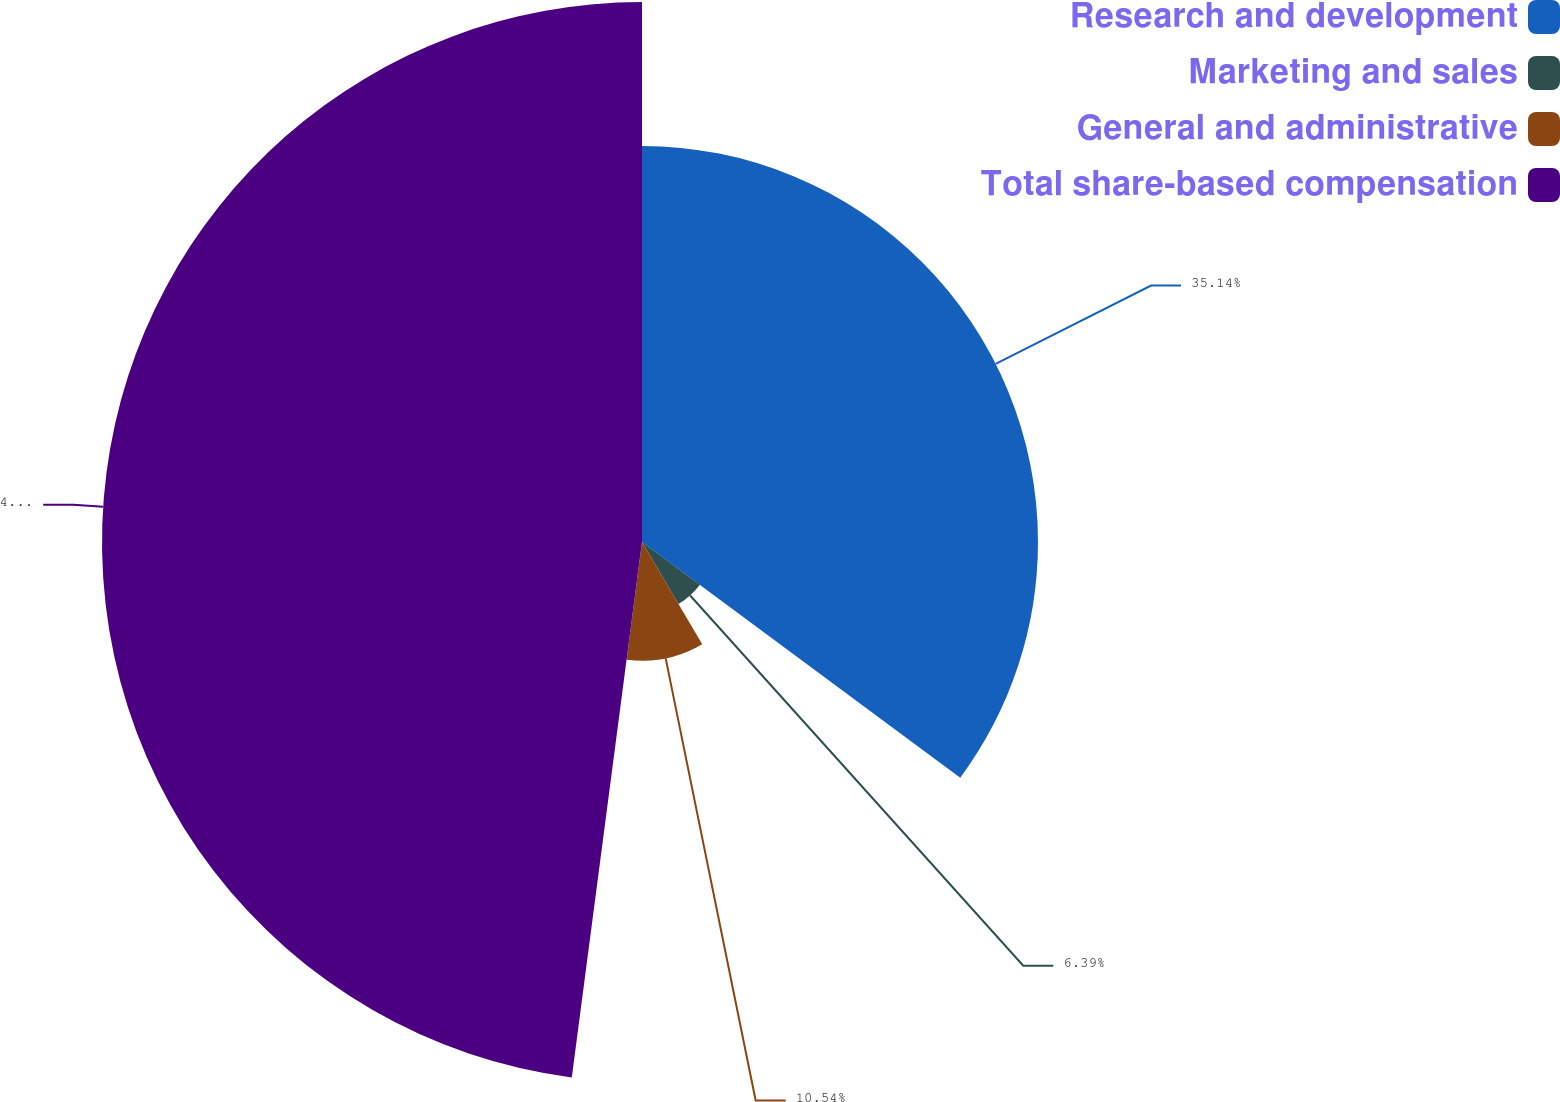<chart> <loc_0><loc_0><loc_500><loc_500><pie_chart><fcel>Research and development<fcel>Marketing and sales<fcel>General and administrative<fcel>Total share-based compensation<nl><fcel>35.14%<fcel>6.39%<fcel>10.54%<fcel>47.92%<nl></chart> 